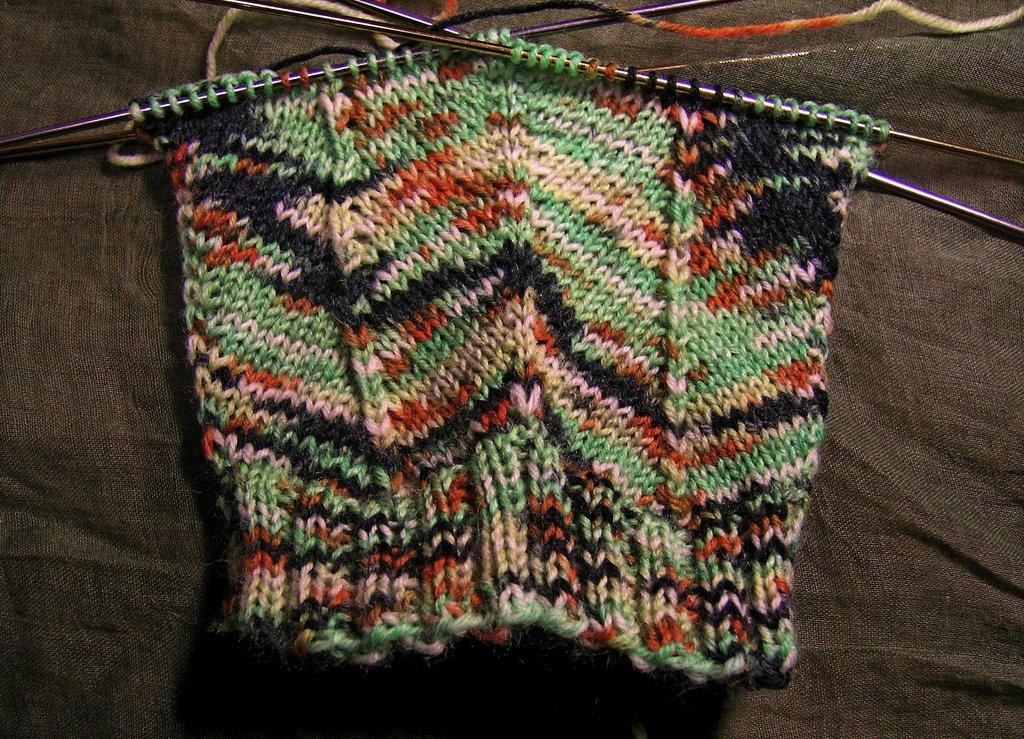What is the main subject in the foreground of the image? There is a woolen cloth in the foreground of the image. What is the woolen cloth placed on? The woolen cloth is on a brown cloth. What objects can be seen at the top of the image? There are hook needles at the top of the image. What type of plate is used to serve the woolen cloth in the morning? There is no plate or morning reference in the image; it only shows a woolen cloth on a brown cloth with hook needles at the top. 